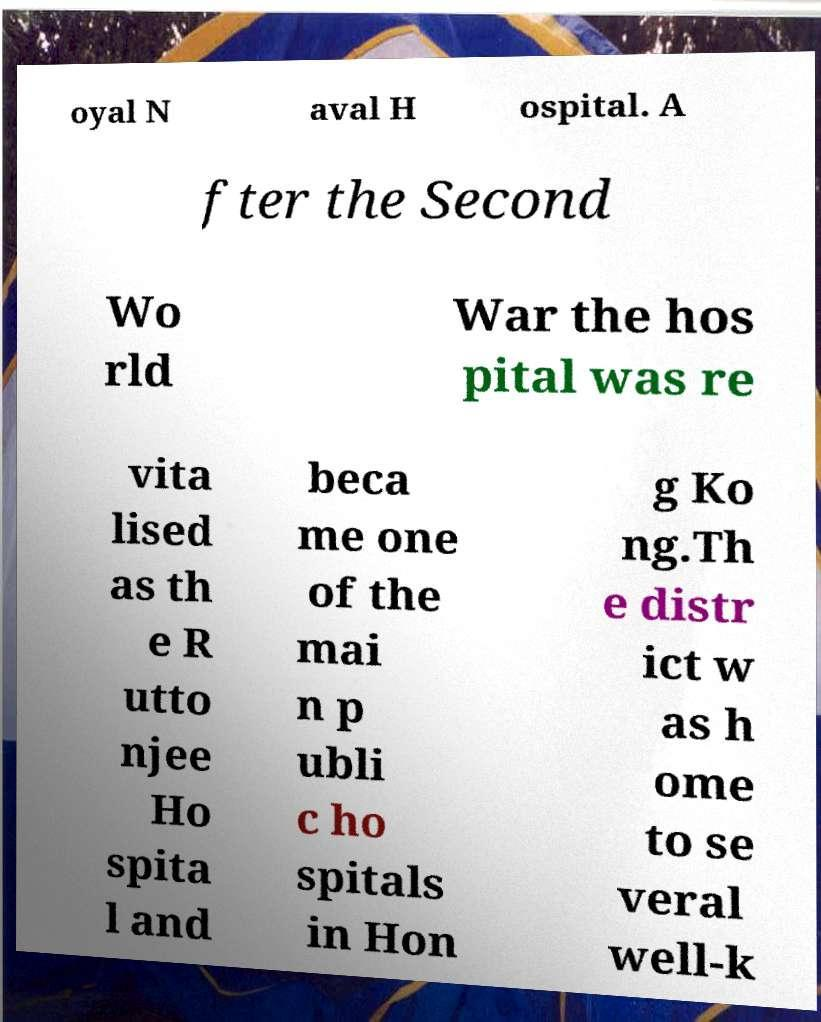What messages or text are displayed in this image? I need them in a readable, typed format. oyal N aval H ospital. A fter the Second Wo rld War the hos pital was re vita lised as th e R utto njee Ho spita l and beca me one of the mai n p ubli c ho spitals in Hon g Ko ng.Th e distr ict w as h ome to se veral well-k 